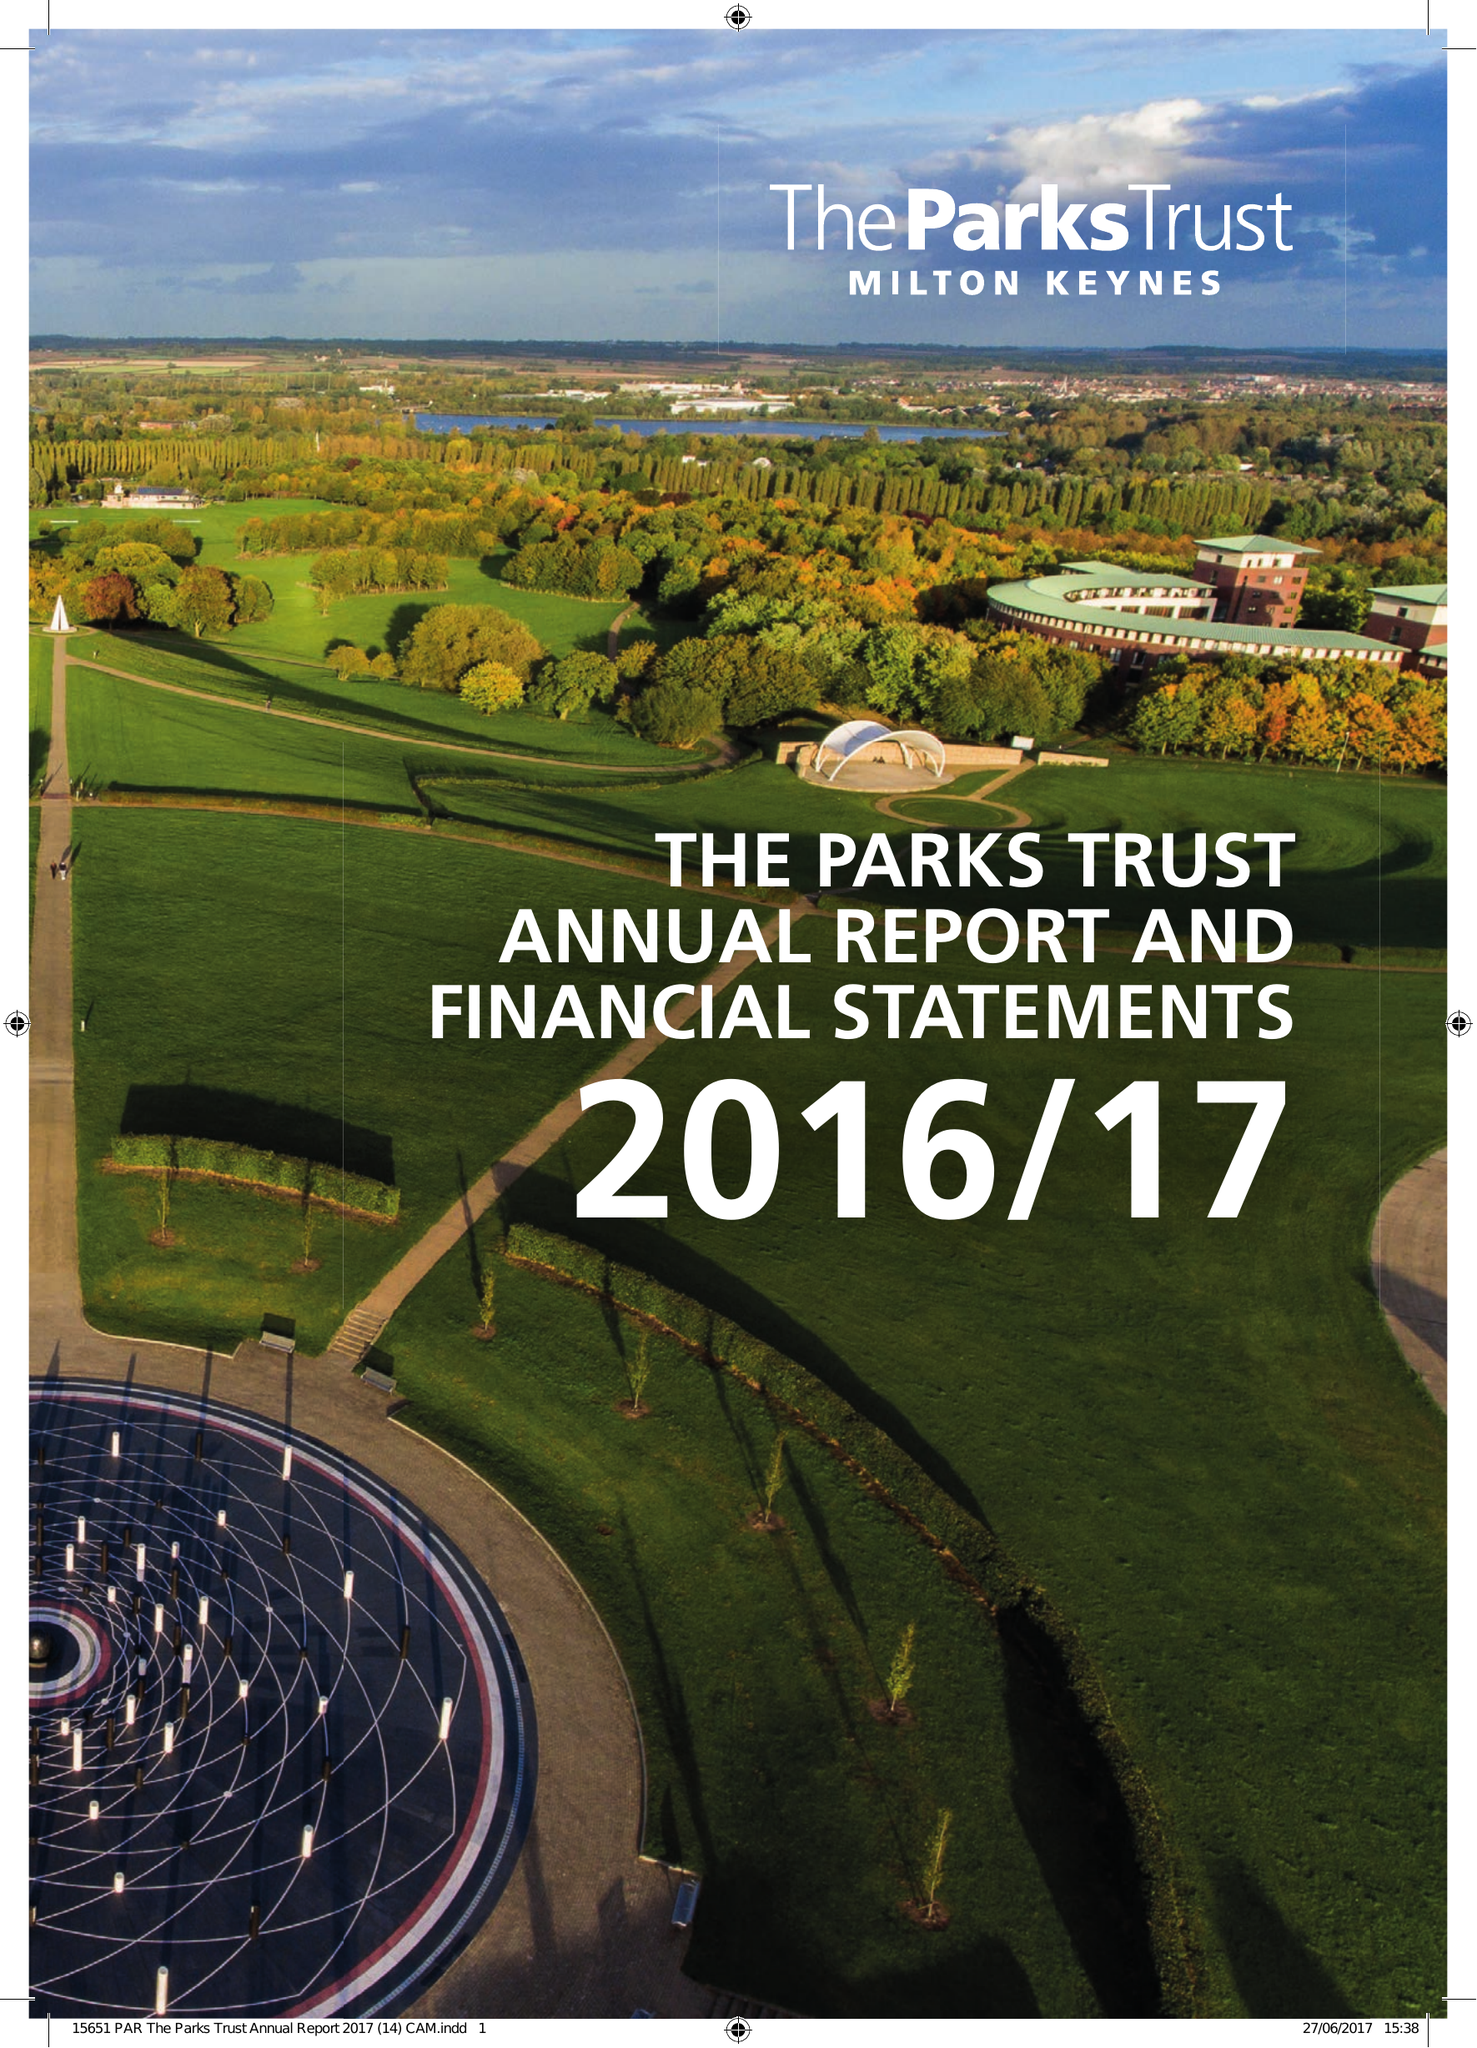What is the value for the spending_annually_in_british_pounds?
Answer the question using a single word or phrase. 10890000.00 